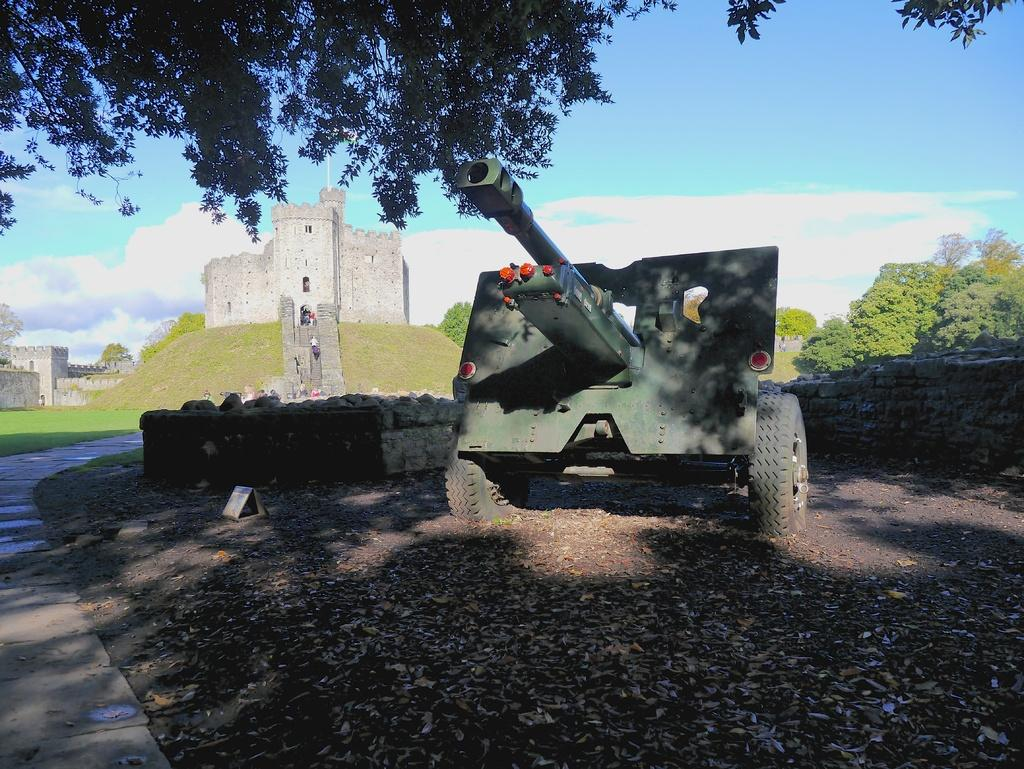What is the main object in the middle of the image? There is a weapon in the middle of the image. What can be seen in the background of the image? There is grass, trees, forts, and clouds in the background of the image. Are there any people visible in the image? Yes, there is a group of people in the background of the image. Where is the map located in the image? There is no map present in the image. Can you see a snake in the image? There is no snake present in the image. 